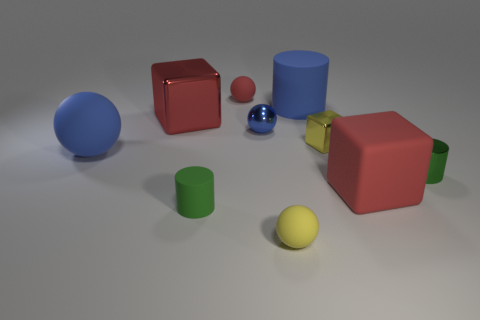How many objects are there in total, and can you categorize them by color? There are a total of seven objects which can be categorized by color as follows: two blue objects (a large sphere and a cylinder), two red objects (both cubes), one green cylinder, one yellow sphere, and one smaller sphere that exhibits a reflective surface resembling chrome.  Which object stands out the most and why? The small sphere with a reflective chrome-like surface stands out the most due to its shiny appearance that contrasts with the matte finish of the other objects, and its reflective surface captures the light and surrounding objects in a way the others do not. 